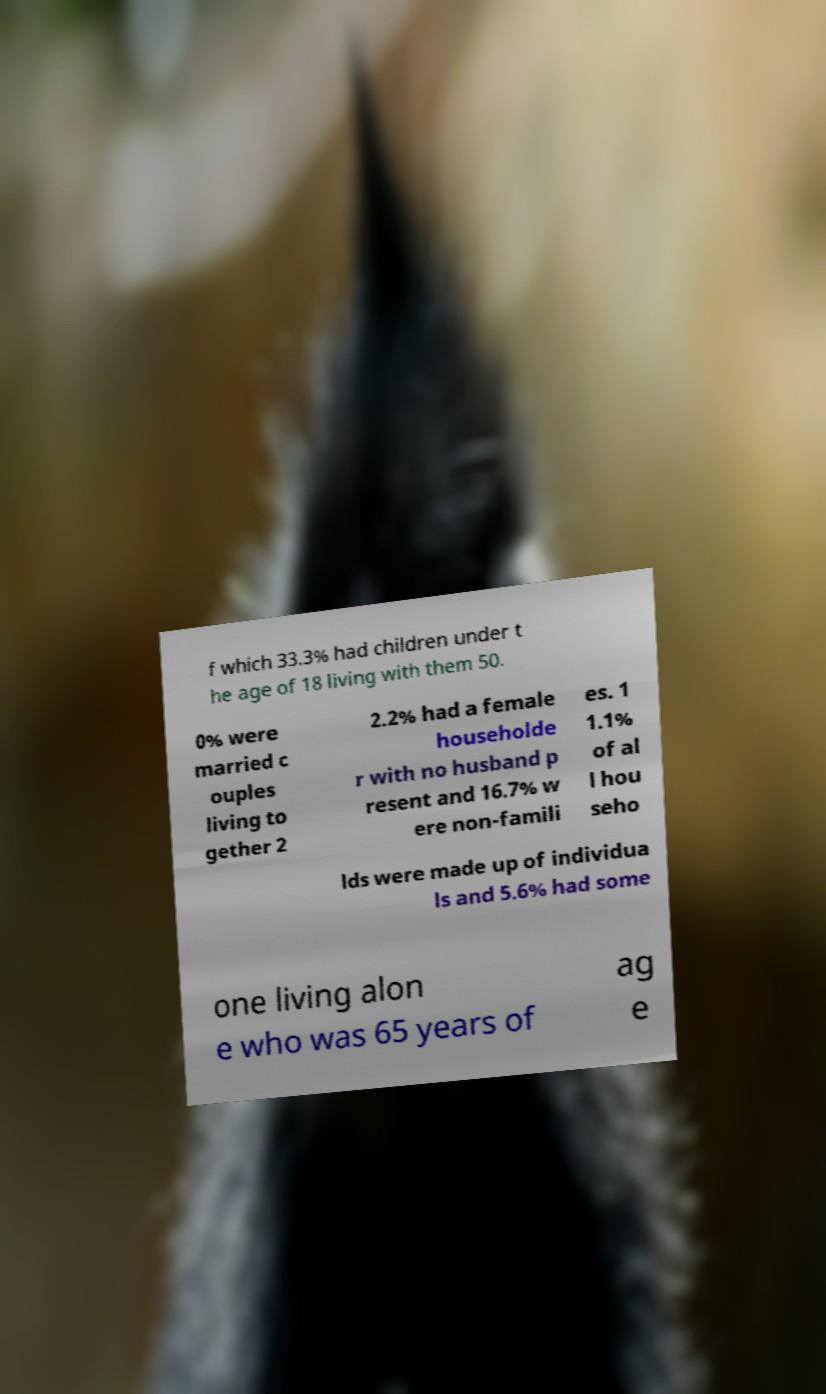Could you assist in decoding the text presented in this image and type it out clearly? f which 33.3% had children under t he age of 18 living with them 50. 0% were married c ouples living to gether 2 2.2% had a female householde r with no husband p resent and 16.7% w ere non-famili es. 1 1.1% of al l hou seho lds were made up of individua ls and 5.6% had some one living alon e who was 65 years of ag e 